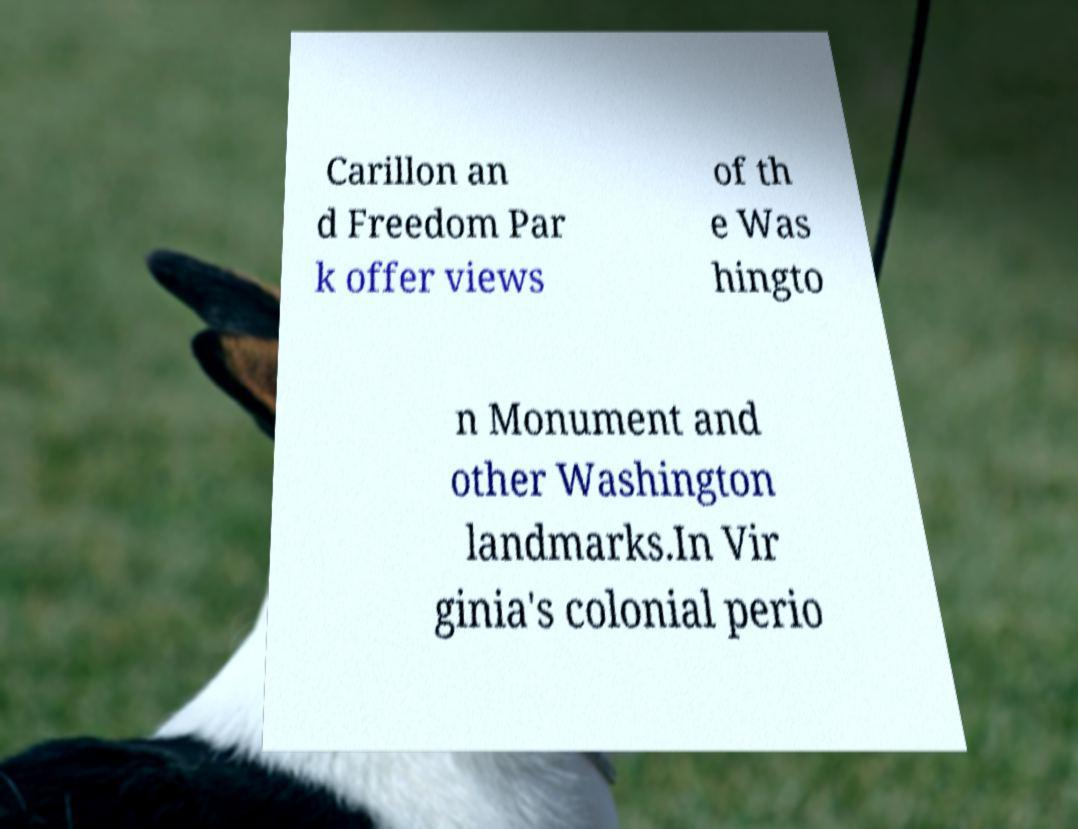Could you assist in decoding the text presented in this image and type it out clearly? Carillon an d Freedom Par k offer views of th e Was hingto n Monument and other Washington landmarks.In Vir ginia's colonial perio 